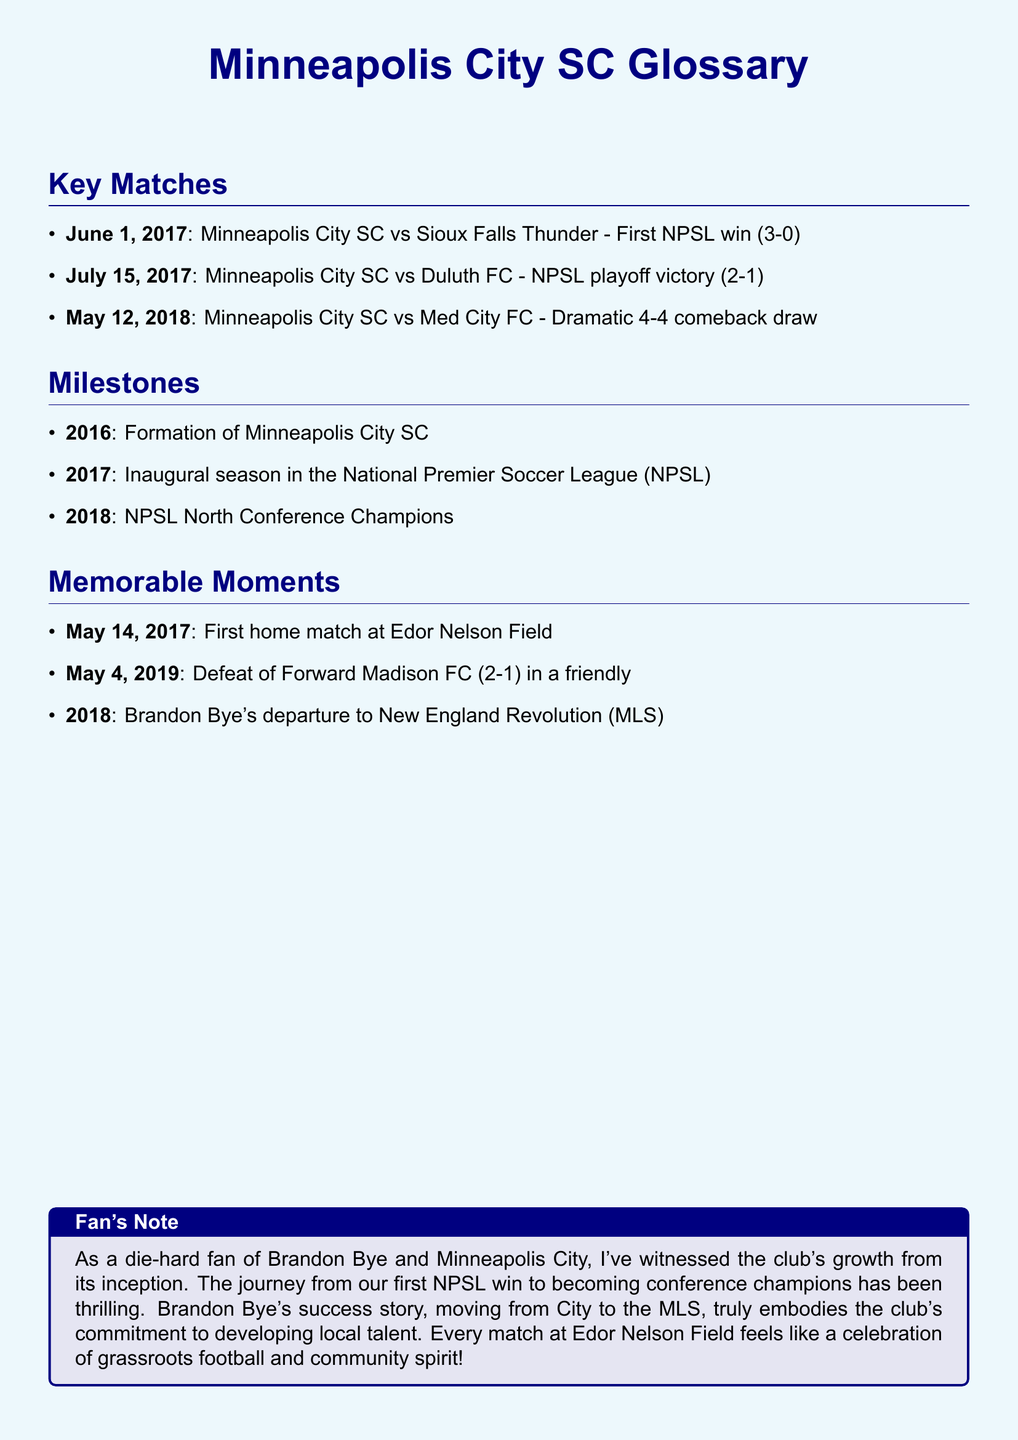What was the date of the first NPSL win? The first NPSL win took place on June 1, 2017.
Answer: June 1, 2017 What was the score of the NPSL playoff victory against Duluth FC? The score of the NPSL playoff victory was 2-1.
Answer: 2-1 In what year was Minneapolis City SC formed? Minneapolis City SC was formed in 2016.
Answer: 2016 Who did Minneapolis City SC defeat in a friendly match on May 4, 2019? They defeated Forward Madison FC in a friendly match.
Answer: Forward Madison FC What notable event occurred on May 14, 2017? The first home match at Edor Nelson Field was held.
Answer: First home match Which title did Minneapolis City SC win in 2018? They won the title of NPSL North Conference Champions.
Answer: NPSL North Conference Champions What is a memorable moment associated with Brandon Bye in 2018? Brandon Bye's departure to New England Revolution (MLS) is a memorable moment.
Answer: Departure to New England Revolution What score did Minneapolis City SC achieve in their dramatic comeback draw against Med City FC? The score of that match was 4-4.
Answer: 4-4 When was the inaugural season for Minneapolis City SC in the NPSL? The inaugural season in the NPSL was in 2017.
Answer: 2017 